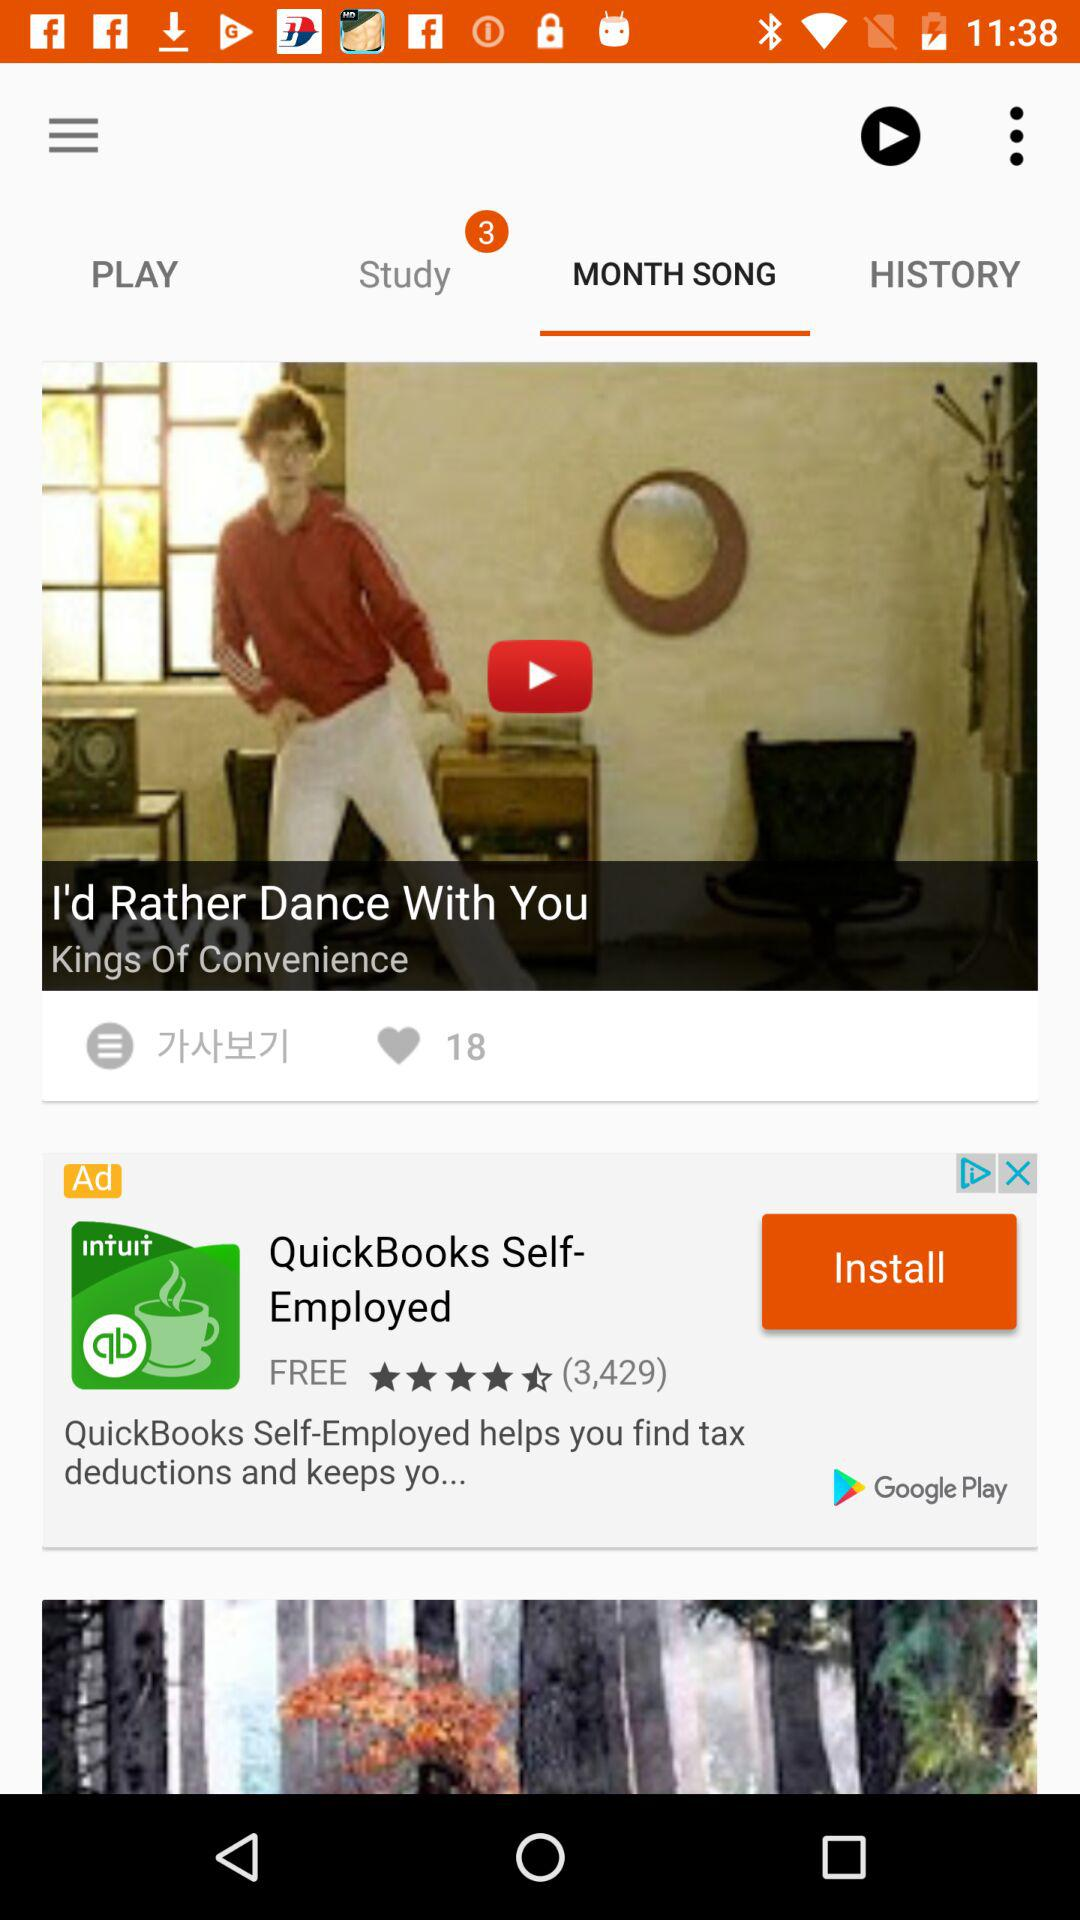Which tab is selected? The selected tab is "MONTH SONG". 